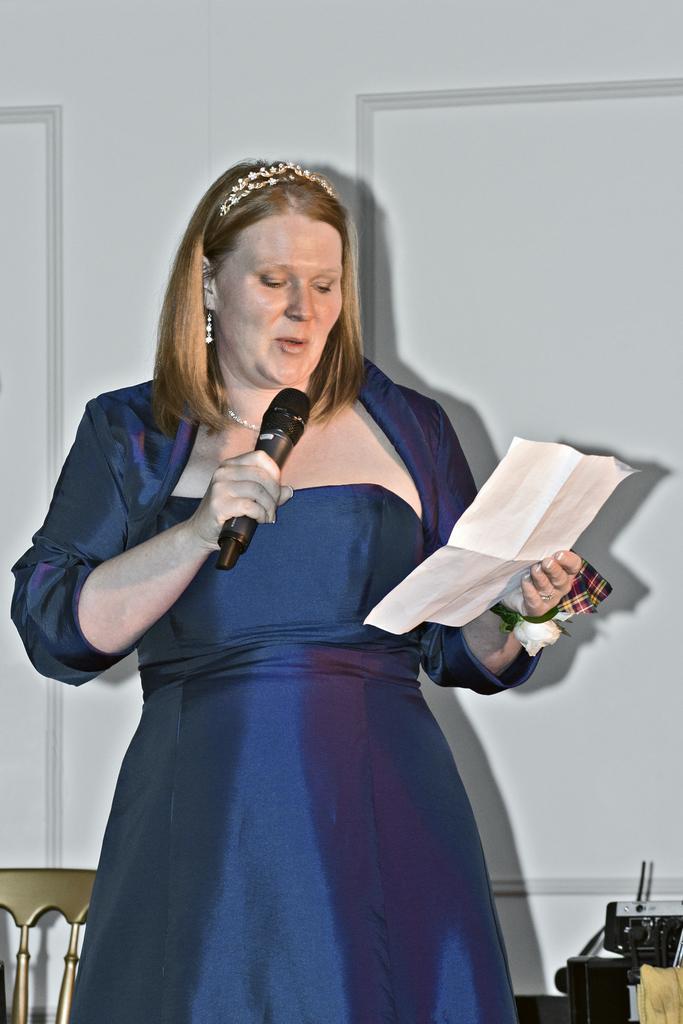Can you describe this image briefly? a person is standing and speaking, holding a microphone in her hand. in other hand there is a paper in which she is seeing and speaking. the woman is wearing a blue dress. behind her there is a white wall. 